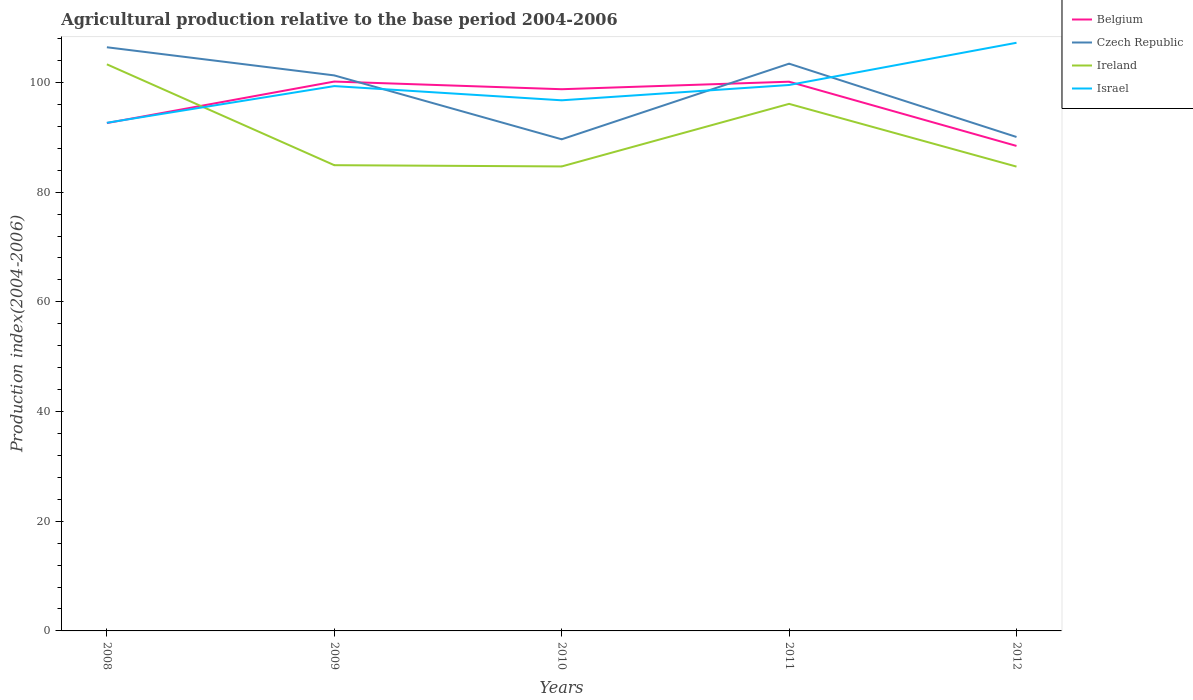How many different coloured lines are there?
Your answer should be very brief. 4. Does the line corresponding to Belgium intersect with the line corresponding to Israel?
Keep it short and to the point. Yes. Across all years, what is the maximum agricultural production index in Israel?
Make the answer very short. 92.65. In which year was the agricultural production index in Czech Republic maximum?
Your answer should be very brief. 2010. What is the total agricultural production index in Czech Republic in the graph?
Offer a terse response. 11.23. What is the difference between the highest and the second highest agricultural production index in Ireland?
Provide a succinct answer. 18.65. Is the agricultural production index in Ireland strictly greater than the agricultural production index in Israel over the years?
Offer a very short reply. No. How many lines are there?
Give a very brief answer. 4. Are the values on the major ticks of Y-axis written in scientific E-notation?
Offer a terse response. No. Does the graph contain any zero values?
Provide a succinct answer. No. Does the graph contain grids?
Your response must be concise. No. How many legend labels are there?
Provide a short and direct response. 4. How are the legend labels stacked?
Your response must be concise. Vertical. What is the title of the graph?
Provide a short and direct response. Agricultural production relative to the base period 2004-2006. What is the label or title of the Y-axis?
Your response must be concise. Production index(2004-2006). What is the Production index(2004-2006) in Belgium in 2008?
Make the answer very short. 92.6. What is the Production index(2004-2006) of Czech Republic in 2008?
Offer a very short reply. 106.42. What is the Production index(2004-2006) of Ireland in 2008?
Make the answer very short. 103.31. What is the Production index(2004-2006) of Israel in 2008?
Ensure brevity in your answer.  92.65. What is the Production index(2004-2006) in Belgium in 2009?
Your answer should be compact. 100.17. What is the Production index(2004-2006) of Czech Republic in 2009?
Your answer should be very brief. 101.29. What is the Production index(2004-2006) in Ireland in 2009?
Keep it short and to the point. 84.92. What is the Production index(2004-2006) in Israel in 2009?
Keep it short and to the point. 99.34. What is the Production index(2004-2006) of Belgium in 2010?
Ensure brevity in your answer.  98.77. What is the Production index(2004-2006) in Czech Republic in 2010?
Your response must be concise. 89.64. What is the Production index(2004-2006) in Ireland in 2010?
Provide a short and direct response. 84.69. What is the Production index(2004-2006) of Israel in 2010?
Give a very brief answer. 96.75. What is the Production index(2004-2006) in Belgium in 2011?
Keep it short and to the point. 100.14. What is the Production index(2004-2006) of Czech Republic in 2011?
Offer a terse response. 103.43. What is the Production index(2004-2006) in Ireland in 2011?
Your response must be concise. 96.1. What is the Production index(2004-2006) in Israel in 2011?
Ensure brevity in your answer.  99.54. What is the Production index(2004-2006) of Belgium in 2012?
Provide a succinct answer. 88.43. What is the Production index(2004-2006) in Czech Republic in 2012?
Your answer should be very brief. 90.06. What is the Production index(2004-2006) of Ireland in 2012?
Ensure brevity in your answer.  84.66. What is the Production index(2004-2006) of Israel in 2012?
Your response must be concise. 107.24. Across all years, what is the maximum Production index(2004-2006) of Belgium?
Your response must be concise. 100.17. Across all years, what is the maximum Production index(2004-2006) of Czech Republic?
Your response must be concise. 106.42. Across all years, what is the maximum Production index(2004-2006) in Ireland?
Provide a short and direct response. 103.31. Across all years, what is the maximum Production index(2004-2006) of Israel?
Provide a succinct answer. 107.24. Across all years, what is the minimum Production index(2004-2006) of Belgium?
Give a very brief answer. 88.43. Across all years, what is the minimum Production index(2004-2006) of Czech Republic?
Your answer should be compact. 89.64. Across all years, what is the minimum Production index(2004-2006) in Ireland?
Provide a short and direct response. 84.66. Across all years, what is the minimum Production index(2004-2006) in Israel?
Provide a short and direct response. 92.65. What is the total Production index(2004-2006) in Belgium in the graph?
Provide a short and direct response. 480.11. What is the total Production index(2004-2006) of Czech Republic in the graph?
Make the answer very short. 490.84. What is the total Production index(2004-2006) of Ireland in the graph?
Your answer should be compact. 453.68. What is the total Production index(2004-2006) in Israel in the graph?
Ensure brevity in your answer.  495.52. What is the difference between the Production index(2004-2006) in Belgium in 2008 and that in 2009?
Offer a very short reply. -7.57. What is the difference between the Production index(2004-2006) of Czech Republic in 2008 and that in 2009?
Give a very brief answer. 5.13. What is the difference between the Production index(2004-2006) of Ireland in 2008 and that in 2009?
Your answer should be compact. 18.39. What is the difference between the Production index(2004-2006) of Israel in 2008 and that in 2009?
Ensure brevity in your answer.  -6.69. What is the difference between the Production index(2004-2006) of Belgium in 2008 and that in 2010?
Keep it short and to the point. -6.17. What is the difference between the Production index(2004-2006) of Czech Republic in 2008 and that in 2010?
Make the answer very short. 16.78. What is the difference between the Production index(2004-2006) in Ireland in 2008 and that in 2010?
Provide a succinct answer. 18.62. What is the difference between the Production index(2004-2006) of Belgium in 2008 and that in 2011?
Offer a very short reply. -7.54. What is the difference between the Production index(2004-2006) of Czech Republic in 2008 and that in 2011?
Your response must be concise. 2.99. What is the difference between the Production index(2004-2006) in Ireland in 2008 and that in 2011?
Ensure brevity in your answer.  7.21. What is the difference between the Production index(2004-2006) of Israel in 2008 and that in 2011?
Your answer should be compact. -6.89. What is the difference between the Production index(2004-2006) of Belgium in 2008 and that in 2012?
Make the answer very short. 4.17. What is the difference between the Production index(2004-2006) of Czech Republic in 2008 and that in 2012?
Keep it short and to the point. 16.36. What is the difference between the Production index(2004-2006) of Ireland in 2008 and that in 2012?
Ensure brevity in your answer.  18.65. What is the difference between the Production index(2004-2006) in Israel in 2008 and that in 2012?
Offer a terse response. -14.59. What is the difference between the Production index(2004-2006) in Belgium in 2009 and that in 2010?
Your response must be concise. 1.4. What is the difference between the Production index(2004-2006) of Czech Republic in 2009 and that in 2010?
Your response must be concise. 11.65. What is the difference between the Production index(2004-2006) of Ireland in 2009 and that in 2010?
Give a very brief answer. 0.23. What is the difference between the Production index(2004-2006) of Israel in 2009 and that in 2010?
Give a very brief answer. 2.59. What is the difference between the Production index(2004-2006) in Belgium in 2009 and that in 2011?
Keep it short and to the point. 0.03. What is the difference between the Production index(2004-2006) of Czech Republic in 2009 and that in 2011?
Offer a terse response. -2.14. What is the difference between the Production index(2004-2006) of Ireland in 2009 and that in 2011?
Give a very brief answer. -11.18. What is the difference between the Production index(2004-2006) in Belgium in 2009 and that in 2012?
Your response must be concise. 11.74. What is the difference between the Production index(2004-2006) of Czech Republic in 2009 and that in 2012?
Your answer should be compact. 11.23. What is the difference between the Production index(2004-2006) in Ireland in 2009 and that in 2012?
Provide a short and direct response. 0.26. What is the difference between the Production index(2004-2006) in Belgium in 2010 and that in 2011?
Your answer should be compact. -1.37. What is the difference between the Production index(2004-2006) of Czech Republic in 2010 and that in 2011?
Keep it short and to the point. -13.79. What is the difference between the Production index(2004-2006) of Ireland in 2010 and that in 2011?
Your answer should be compact. -11.41. What is the difference between the Production index(2004-2006) of Israel in 2010 and that in 2011?
Give a very brief answer. -2.79. What is the difference between the Production index(2004-2006) of Belgium in 2010 and that in 2012?
Offer a terse response. 10.34. What is the difference between the Production index(2004-2006) of Czech Republic in 2010 and that in 2012?
Provide a succinct answer. -0.42. What is the difference between the Production index(2004-2006) of Ireland in 2010 and that in 2012?
Provide a short and direct response. 0.03. What is the difference between the Production index(2004-2006) in Israel in 2010 and that in 2012?
Ensure brevity in your answer.  -10.49. What is the difference between the Production index(2004-2006) of Belgium in 2011 and that in 2012?
Offer a terse response. 11.71. What is the difference between the Production index(2004-2006) in Czech Republic in 2011 and that in 2012?
Your response must be concise. 13.37. What is the difference between the Production index(2004-2006) of Ireland in 2011 and that in 2012?
Make the answer very short. 11.44. What is the difference between the Production index(2004-2006) in Israel in 2011 and that in 2012?
Provide a short and direct response. -7.7. What is the difference between the Production index(2004-2006) of Belgium in 2008 and the Production index(2004-2006) of Czech Republic in 2009?
Keep it short and to the point. -8.69. What is the difference between the Production index(2004-2006) in Belgium in 2008 and the Production index(2004-2006) in Ireland in 2009?
Offer a very short reply. 7.68. What is the difference between the Production index(2004-2006) in Belgium in 2008 and the Production index(2004-2006) in Israel in 2009?
Offer a very short reply. -6.74. What is the difference between the Production index(2004-2006) in Czech Republic in 2008 and the Production index(2004-2006) in Ireland in 2009?
Make the answer very short. 21.5. What is the difference between the Production index(2004-2006) in Czech Republic in 2008 and the Production index(2004-2006) in Israel in 2009?
Make the answer very short. 7.08. What is the difference between the Production index(2004-2006) in Ireland in 2008 and the Production index(2004-2006) in Israel in 2009?
Offer a very short reply. 3.97. What is the difference between the Production index(2004-2006) of Belgium in 2008 and the Production index(2004-2006) of Czech Republic in 2010?
Keep it short and to the point. 2.96. What is the difference between the Production index(2004-2006) of Belgium in 2008 and the Production index(2004-2006) of Ireland in 2010?
Provide a succinct answer. 7.91. What is the difference between the Production index(2004-2006) of Belgium in 2008 and the Production index(2004-2006) of Israel in 2010?
Your answer should be very brief. -4.15. What is the difference between the Production index(2004-2006) of Czech Republic in 2008 and the Production index(2004-2006) of Ireland in 2010?
Offer a very short reply. 21.73. What is the difference between the Production index(2004-2006) of Czech Republic in 2008 and the Production index(2004-2006) of Israel in 2010?
Your answer should be very brief. 9.67. What is the difference between the Production index(2004-2006) in Ireland in 2008 and the Production index(2004-2006) in Israel in 2010?
Give a very brief answer. 6.56. What is the difference between the Production index(2004-2006) in Belgium in 2008 and the Production index(2004-2006) in Czech Republic in 2011?
Make the answer very short. -10.83. What is the difference between the Production index(2004-2006) of Belgium in 2008 and the Production index(2004-2006) of Ireland in 2011?
Provide a short and direct response. -3.5. What is the difference between the Production index(2004-2006) of Belgium in 2008 and the Production index(2004-2006) of Israel in 2011?
Make the answer very short. -6.94. What is the difference between the Production index(2004-2006) in Czech Republic in 2008 and the Production index(2004-2006) in Ireland in 2011?
Your answer should be compact. 10.32. What is the difference between the Production index(2004-2006) of Czech Republic in 2008 and the Production index(2004-2006) of Israel in 2011?
Give a very brief answer. 6.88. What is the difference between the Production index(2004-2006) in Ireland in 2008 and the Production index(2004-2006) in Israel in 2011?
Keep it short and to the point. 3.77. What is the difference between the Production index(2004-2006) in Belgium in 2008 and the Production index(2004-2006) in Czech Republic in 2012?
Make the answer very short. 2.54. What is the difference between the Production index(2004-2006) of Belgium in 2008 and the Production index(2004-2006) of Ireland in 2012?
Your response must be concise. 7.94. What is the difference between the Production index(2004-2006) in Belgium in 2008 and the Production index(2004-2006) in Israel in 2012?
Offer a terse response. -14.64. What is the difference between the Production index(2004-2006) of Czech Republic in 2008 and the Production index(2004-2006) of Ireland in 2012?
Provide a short and direct response. 21.76. What is the difference between the Production index(2004-2006) of Czech Republic in 2008 and the Production index(2004-2006) of Israel in 2012?
Your answer should be compact. -0.82. What is the difference between the Production index(2004-2006) in Ireland in 2008 and the Production index(2004-2006) in Israel in 2012?
Make the answer very short. -3.93. What is the difference between the Production index(2004-2006) in Belgium in 2009 and the Production index(2004-2006) in Czech Republic in 2010?
Your response must be concise. 10.53. What is the difference between the Production index(2004-2006) of Belgium in 2009 and the Production index(2004-2006) of Ireland in 2010?
Your response must be concise. 15.48. What is the difference between the Production index(2004-2006) of Belgium in 2009 and the Production index(2004-2006) of Israel in 2010?
Give a very brief answer. 3.42. What is the difference between the Production index(2004-2006) of Czech Republic in 2009 and the Production index(2004-2006) of Israel in 2010?
Offer a very short reply. 4.54. What is the difference between the Production index(2004-2006) in Ireland in 2009 and the Production index(2004-2006) in Israel in 2010?
Provide a short and direct response. -11.83. What is the difference between the Production index(2004-2006) of Belgium in 2009 and the Production index(2004-2006) of Czech Republic in 2011?
Give a very brief answer. -3.26. What is the difference between the Production index(2004-2006) of Belgium in 2009 and the Production index(2004-2006) of Ireland in 2011?
Your answer should be compact. 4.07. What is the difference between the Production index(2004-2006) in Belgium in 2009 and the Production index(2004-2006) in Israel in 2011?
Your response must be concise. 0.63. What is the difference between the Production index(2004-2006) of Czech Republic in 2009 and the Production index(2004-2006) of Ireland in 2011?
Make the answer very short. 5.19. What is the difference between the Production index(2004-2006) of Ireland in 2009 and the Production index(2004-2006) of Israel in 2011?
Offer a very short reply. -14.62. What is the difference between the Production index(2004-2006) in Belgium in 2009 and the Production index(2004-2006) in Czech Republic in 2012?
Provide a short and direct response. 10.11. What is the difference between the Production index(2004-2006) of Belgium in 2009 and the Production index(2004-2006) of Ireland in 2012?
Offer a terse response. 15.51. What is the difference between the Production index(2004-2006) in Belgium in 2009 and the Production index(2004-2006) in Israel in 2012?
Make the answer very short. -7.07. What is the difference between the Production index(2004-2006) in Czech Republic in 2009 and the Production index(2004-2006) in Ireland in 2012?
Provide a short and direct response. 16.63. What is the difference between the Production index(2004-2006) in Czech Republic in 2009 and the Production index(2004-2006) in Israel in 2012?
Provide a succinct answer. -5.95. What is the difference between the Production index(2004-2006) of Ireland in 2009 and the Production index(2004-2006) of Israel in 2012?
Provide a succinct answer. -22.32. What is the difference between the Production index(2004-2006) of Belgium in 2010 and the Production index(2004-2006) of Czech Republic in 2011?
Keep it short and to the point. -4.66. What is the difference between the Production index(2004-2006) of Belgium in 2010 and the Production index(2004-2006) of Ireland in 2011?
Ensure brevity in your answer.  2.67. What is the difference between the Production index(2004-2006) in Belgium in 2010 and the Production index(2004-2006) in Israel in 2011?
Ensure brevity in your answer.  -0.77. What is the difference between the Production index(2004-2006) of Czech Republic in 2010 and the Production index(2004-2006) of Ireland in 2011?
Provide a succinct answer. -6.46. What is the difference between the Production index(2004-2006) in Czech Republic in 2010 and the Production index(2004-2006) in Israel in 2011?
Your response must be concise. -9.9. What is the difference between the Production index(2004-2006) in Ireland in 2010 and the Production index(2004-2006) in Israel in 2011?
Give a very brief answer. -14.85. What is the difference between the Production index(2004-2006) of Belgium in 2010 and the Production index(2004-2006) of Czech Republic in 2012?
Offer a terse response. 8.71. What is the difference between the Production index(2004-2006) in Belgium in 2010 and the Production index(2004-2006) in Ireland in 2012?
Your answer should be compact. 14.11. What is the difference between the Production index(2004-2006) of Belgium in 2010 and the Production index(2004-2006) of Israel in 2012?
Keep it short and to the point. -8.47. What is the difference between the Production index(2004-2006) in Czech Republic in 2010 and the Production index(2004-2006) in Ireland in 2012?
Give a very brief answer. 4.98. What is the difference between the Production index(2004-2006) in Czech Republic in 2010 and the Production index(2004-2006) in Israel in 2012?
Offer a terse response. -17.6. What is the difference between the Production index(2004-2006) in Ireland in 2010 and the Production index(2004-2006) in Israel in 2012?
Keep it short and to the point. -22.55. What is the difference between the Production index(2004-2006) of Belgium in 2011 and the Production index(2004-2006) of Czech Republic in 2012?
Give a very brief answer. 10.08. What is the difference between the Production index(2004-2006) in Belgium in 2011 and the Production index(2004-2006) in Ireland in 2012?
Ensure brevity in your answer.  15.48. What is the difference between the Production index(2004-2006) in Czech Republic in 2011 and the Production index(2004-2006) in Ireland in 2012?
Provide a succinct answer. 18.77. What is the difference between the Production index(2004-2006) in Czech Republic in 2011 and the Production index(2004-2006) in Israel in 2012?
Provide a succinct answer. -3.81. What is the difference between the Production index(2004-2006) in Ireland in 2011 and the Production index(2004-2006) in Israel in 2012?
Offer a terse response. -11.14. What is the average Production index(2004-2006) of Belgium per year?
Provide a succinct answer. 96.02. What is the average Production index(2004-2006) in Czech Republic per year?
Provide a short and direct response. 98.17. What is the average Production index(2004-2006) in Ireland per year?
Your answer should be very brief. 90.74. What is the average Production index(2004-2006) of Israel per year?
Provide a succinct answer. 99.1. In the year 2008, what is the difference between the Production index(2004-2006) in Belgium and Production index(2004-2006) in Czech Republic?
Provide a succinct answer. -13.82. In the year 2008, what is the difference between the Production index(2004-2006) in Belgium and Production index(2004-2006) in Ireland?
Ensure brevity in your answer.  -10.71. In the year 2008, what is the difference between the Production index(2004-2006) of Czech Republic and Production index(2004-2006) of Ireland?
Your answer should be compact. 3.11. In the year 2008, what is the difference between the Production index(2004-2006) of Czech Republic and Production index(2004-2006) of Israel?
Provide a short and direct response. 13.77. In the year 2008, what is the difference between the Production index(2004-2006) in Ireland and Production index(2004-2006) in Israel?
Ensure brevity in your answer.  10.66. In the year 2009, what is the difference between the Production index(2004-2006) of Belgium and Production index(2004-2006) of Czech Republic?
Ensure brevity in your answer.  -1.12. In the year 2009, what is the difference between the Production index(2004-2006) in Belgium and Production index(2004-2006) in Ireland?
Your answer should be compact. 15.25. In the year 2009, what is the difference between the Production index(2004-2006) of Belgium and Production index(2004-2006) of Israel?
Provide a succinct answer. 0.83. In the year 2009, what is the difference between the Production index(2004-2006) in Czech Republic and Production index(2004-2006) in Ireland?
Ensure brevity in your answer.  16.37. In the year 2009, what is the difference between the Production index(2004-2006) in Czech Republic and Production index(2004-2006) in Israel?
Offer a very short reply. 1.95. In the year 2009, what is the difference between the Production index(2004-2006) of Ireland and Production index(2004-2006) of Israel?
Provide a succinct answer. -14.42. In the year 2010, what is the difference between the Production index(2004-2006) of Belgium and Production index(2004-2006) of Czech Republic?
Keep it short and to the point. 9.13. In the year 2010, what is the difference between the Production index(2004-2006) in Belgium and Production index(2004-2006) in Ireland?
Your response must be concise. 14.08. In the year 2010, what is the difference between the Production index(2004-2006) of Belgium and Production index(2004-2006) of Israel?
Offer a very short reply. 2.02. In the year 2010, what is the difference between the Production index(2004-2006) of Czech Republic and Production index(2004-2006) of Ireland?
Your answer should be very brief. 4.95. In the year 2010, what is the difference between the Production index(2004-2006) in Czech Republic and Production index(2004-2006) in Israel?
Ensure brevity in your answer.  -7.11. In the year 2010, what is the difference between the Production index(2004-2006) in Ireland and Production index(2004-2006) in Israel?
Keep it short and to the point. -12.06. In the year 2011, what is the difference between the Production index(2004-2006) in Belgium and Production index(2004-2006) in Czech Republic?
Provide a short and direct response. -3.29. In the year 2011, what is the difference between the Production index(2004-2006) in Belgium and Production index(2004-2006) in Ireland?
Ensure brevity in your answer.  4.04. In the year 2011, what is the difference between the Production index(2004-2006) of Belgium and Production index(2004-2006) of Israel?
Offer a very short reply. 0.6. In the year 2011, what is the difference between the Production index(2004-2006) of Czech Republic and Production index(2004-2006) of Ireland?
Your answer should be very brief. 7.33. In the year 2011, what is the difference between the Production index(2004-2006) in Czech Republic and Production index(2004-2006) in Israel?
Provide a short and direct response. 3.89. In the year 2011, what is the difference between the Production index(2004-2006) in Ireland and Production index(2004-2006) in Israel?
Provide a succinct answer. -3.44. In the year 2012, what is the difference between the Production index(2004-2006) in Belgium and Production index(2004-2006) in Czech Republic?
Offer a terse response. -1.63. In the year 2012, what is the difference between the Production index(2004-2006) of Belgium and Production index(2004-2006) of Ireland?
Your answer should be compact. 3.77. In the year 2012, what is the difference between the Production index(2004-2006) of Belgium and Production index(2004-2006) of Israel?
Keep it short and to the point. -18.81. In the year 2012, what is the difference between the Production index(2004-2006) of Czech Republic and Production index(2004-2006) of Israel?
Ensure brevity in your answer.  -17.18. In the year 2012, what is the difference between the Production index(2004-2006) of Ireland and Production index(2004-2006) of Israel?
Provide a succinct answer. -22.58. What is the ratio of the Production index(2004-2006) in Belgium in 2008 to that in 2009?
Provide a succinct answer. 0.92. What is the ratio of the Production index(2004-2006) in Czech Republic in 2008 to that in 2009?
Make the answer very short. 1.05. What is the ratio of the Production index(2004-2006) in Ireland in 2008 to that in 2009?
Keep it short and to the point. 1.22. What is the ratio of the Production index(2004-2006) of Israel in 2008 to that in 2009?
Offer a terse response. 0.93. What is the ratio of the Production index(2004-2006) in Czech Republic in 2008 to that in 2010?
Provide a short and direct response. 1.19. What is the ratio of the Production index(2004-2006) of Ireland in 2008 to that in 2010?
Give a very brief answer. 1.22. What is the ratio of the Production index(2004-2006) of Israel in 2008 to that in 2010?
Offer a very short reply. 0.96. What is the ratio of the Production index(2004-2006) of Belgium in 2008 to that in 2011?
Give a very brief answer. 0.92. What is the ratio of the Production index(2004-2006) of Czech Republic in 2008 to that in 2011?
Your response must be concise. 1.03. What is the ratio of the Production index(2004-2006) in Ireland in 2008 to that in 2011?
Make the answer very short. 1.07. What is the ratio of the Production index(2004-2006) of Israel in 2008 to that in 2011?
Your answer should be very brief. 0.93. What is the ratio of the Production index(2004-2006) in Belgium in 2008 to that in 2012?
Keep it short and to the point. 1.05. What is the ratio of the Production index(2004-2006) in Czech Republic in 2008 to that in 2012?
Your answer should be compact. 1.18. What is the ratio of the Production index(2004-2006) in Ireland in 2008 to that in 2012?
Ensure brevity in your answer.  1.22. What is the ratio of the Production index(2004-2006) of Israel in 2008 to that in 2012?
Offer a very short reply. 0.86. What is the ratio of the Production index(2004-2006) in Belgium in 2009 to that in 2010?
Offer a very short reply. 1.01. What is the ratio of the Production index(2004-2006) in Czech Republic in 2009 to that in 2010?
Offer a very short reply. 1.13. What is the ratio of the Production index(2004-2006) of Israel in 2009 to that in 2010?
Offer a terse response. 1.03. What is the ratio of the Production index(2004-2006) in Belgium in 2009 to that in 2011?
Your answer should be very brief. 1. What is the ratio of the Production index(2004-2006) of Czech Republic in 2009 to that in 2011?
Make the answer very short. 0.98. What is the ratio of the Production index(2004-2006) in Ireland in 2009 to that in 2011?
Ensure brevity in your answer.  0.88. What is the ratio of the Production index(2004-2006) of Belgium in 2009 to that in 2012?
Offer a terse response. 1.13. What is the ratio of the Production index(2004-2006) of Czech Republic in 2009 to that in 2012?
Keep it short and to the point. 1.12. What is the ratio of the Production index(2004-2006) in Israel in 2009 to that in 2012?
Make the answer very short. 0.93. What is the ratio of the Production index(2004-2006) in Belgium in 2010 to that in 2011?
Your answer should be very brief. 0.99. What is the ratio of the Production index(2004-2006) in Czech Republic in 2010 to that in 2011?
Offer a very short reply. 0.87. What is the ratio of the Production index(2004-2006) of Ireland in 2010 to that in 2011?
Your answer should be compact. 0.88. What is the ratio of the Production index(2004-2006) in Belgium in 2010 to that in 2012?
Offer a very short reply. 1.12. What is the ratio of the Production index(2004-2006) of Czech Republic in 2010 to that in 2012?
Offer a very short reply. 1. What is the ratio of the Production index(2004-2006) in Ireland in 2010 to that in 2012?
Ensure brevity in your answer.  1. What is the ratio of the Production index(2004-2006) of Israel in 2010 to that in 2012?
Ensure brevity in your answer.  0.9. What is the ratio of the Production index(2004-2006) in Belgium in 2011 to that in 2012?
Give a very brief answer. 1.13. What is the ratio of the Production index(2004-2006) in Czech Republic in 2011 to that in 2012?
Offer a terse response. 1.15. What is the ratio of the Production index(2004-2006) in Ireland in 2011 to that in 2012?
Your answer should be very brief. 1.14. What is the ratio of the Production index(2004-2006) in Israel in 2011 to that in 2012?
Keep it short and to the point. 0.93. What is the difference between the highest and the second highest Production index(2004-2006) in Belgium?
Offer a terse response. 0.03. What is the difference between the highest and the second highest Production index(2004-2006) of Czech Republic?
Your response must be concise. 2.99. What is the difference between the highest and the second highest Production index(2004-2006) of Ireland?
Provide a short and direct response. 7.21. What is the difference between the highest and the lowest Production index(2004-2006) of Belgium?
Your response must be concise. 11.74. What is the difference between the highest and the lowest Production index(2004-2006) in Czech Republic?
Keep it short and to the point. 16.78. What is the difference between the highest and the lowest Production index(2004-2006) in Ireland?
Your answer should be very brief. 18.65. What is the difference between the highest and the lowest Production index(2004-2006) of Israel?
Offer a terse response. 14.59. 